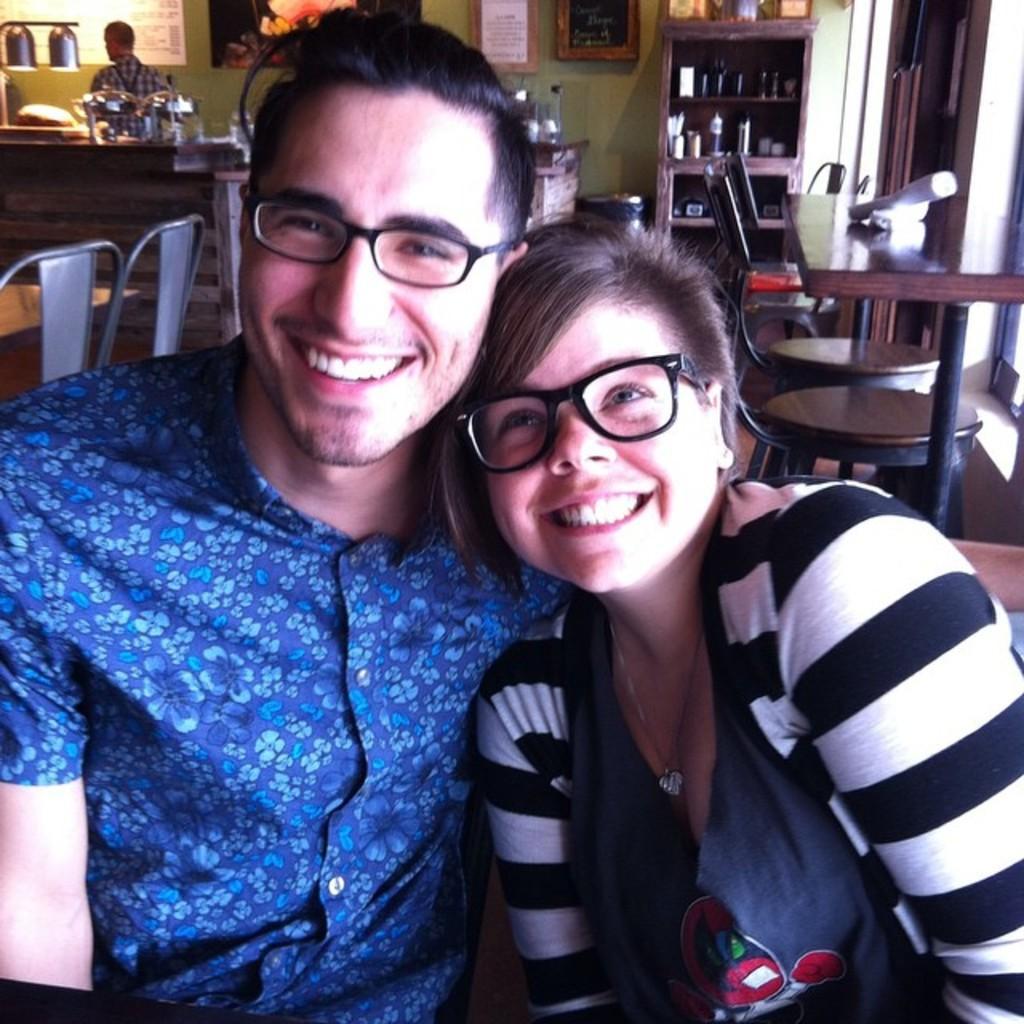Please provide a concise description of this image. In the foreground of the picture I can see a couple and there is a smile on their face. I can see the tables and chairs on the floor. I can see the wooden shelf on the top right side. There is a man on the top left side of the picture. 